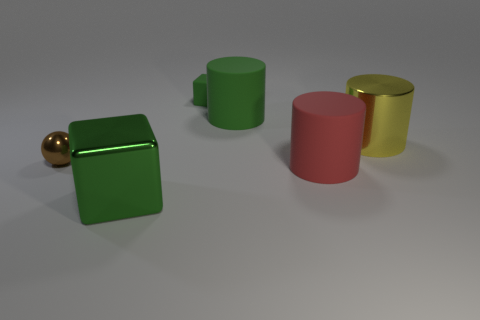What is the size of the cylinder that is the same color as the tiny cube?
Your response must be concise. Large. Is there a large metal thing in front of the tiny object that is behind the green rubber thing to the right of the small green matte thing?
Ensure brevity in your answer.  Yes. What is the material of the other tiny green object that is the same shape as the green metal object?
Your response must be concise. Rubber. What color is the metal cylinder that is on the right side of the small metallic ball?
Make the answer very short. Yellow. The brown metal thing is what size?
Keep it short and to the point. Small. There is a brown metallic object; is its size the same as the yellow shiny cylinder to the right of the green metallic cube?
Your response must be concise. No. The small thing that is right of the small thing in front of the green cube that is behind the big red matte cylinder is what color?
Your response must be concise. Green. Do the large green thing on the left side of the big green matte thing and the small ball have the same material?
Your answer should be compact. Yes. How many other things are there of the same material as the yellow object?
Your answer should be very brief. 2. There is a cube that is the same size as the yellow cylinder; what is it made of?
Give a very brief answer. Metal. 